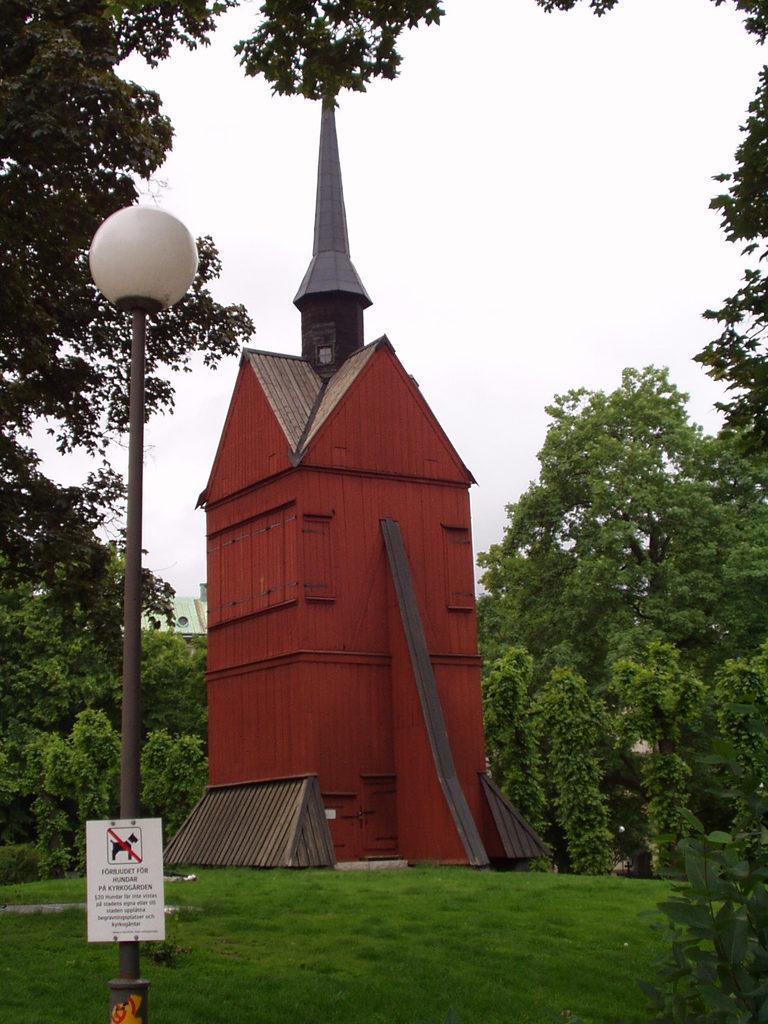In one or two sentences, can you explain what this image depicts? This looks like a building. I can see the grass. This is a signboard, which is attached to a light pole. These are the trees with branches and leaves. I can see a spire, which is at the top of a building. This is the sky. 